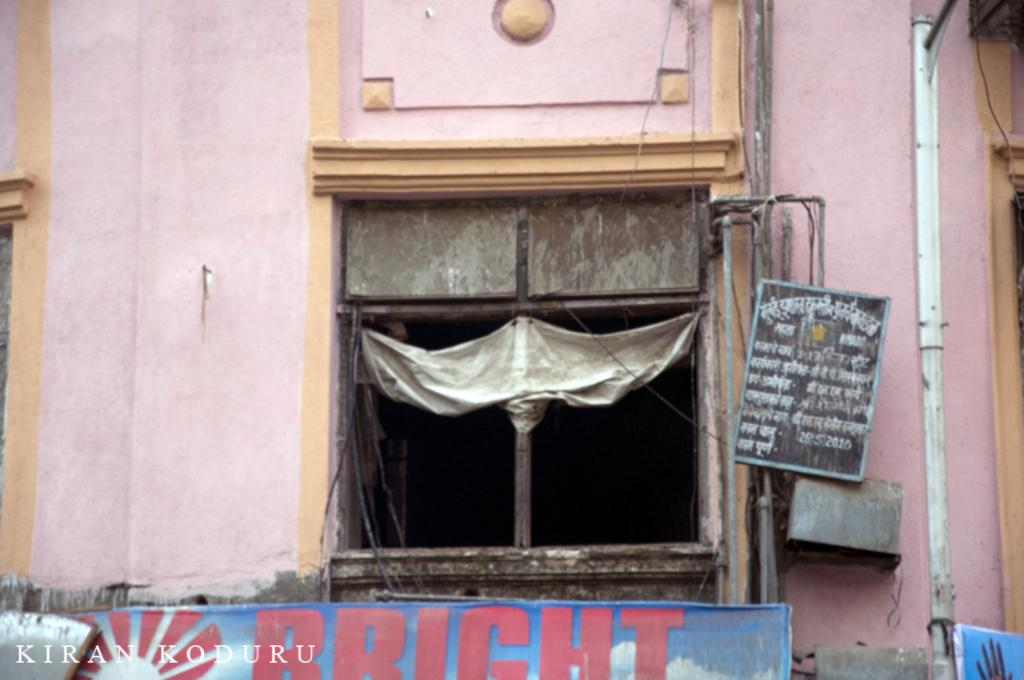What can be seen in the middle of the image? There is a window in the middle of the image. What is on the window? There is a poster on the window. What word is printed on the poster? The word "BRIGHT" is printed on the poster. What else is visible in the image besides the window and poster? There is a wall visible in the image. How many cherries are hanging from the window in the image? There are no cherries present in the image; the poster on the window features the word "BRIGHT." 